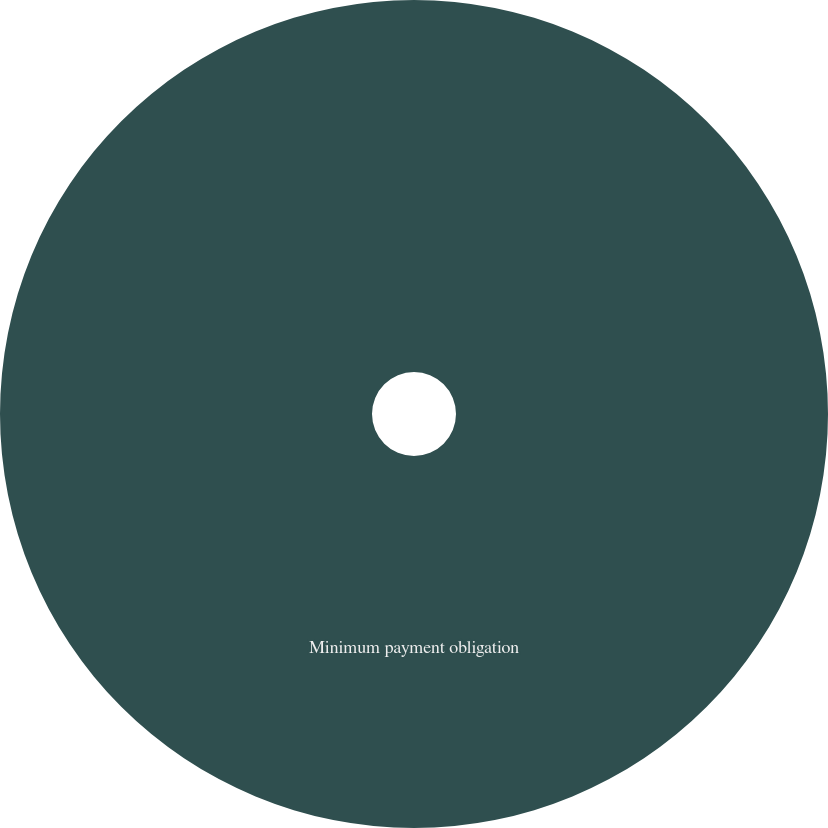<chart> <loc_0><loc_0><loc_500><loc_500><pie_chart><fcel>Minimum payment obligation<nl><fcel>100.0%<nl></chart> 